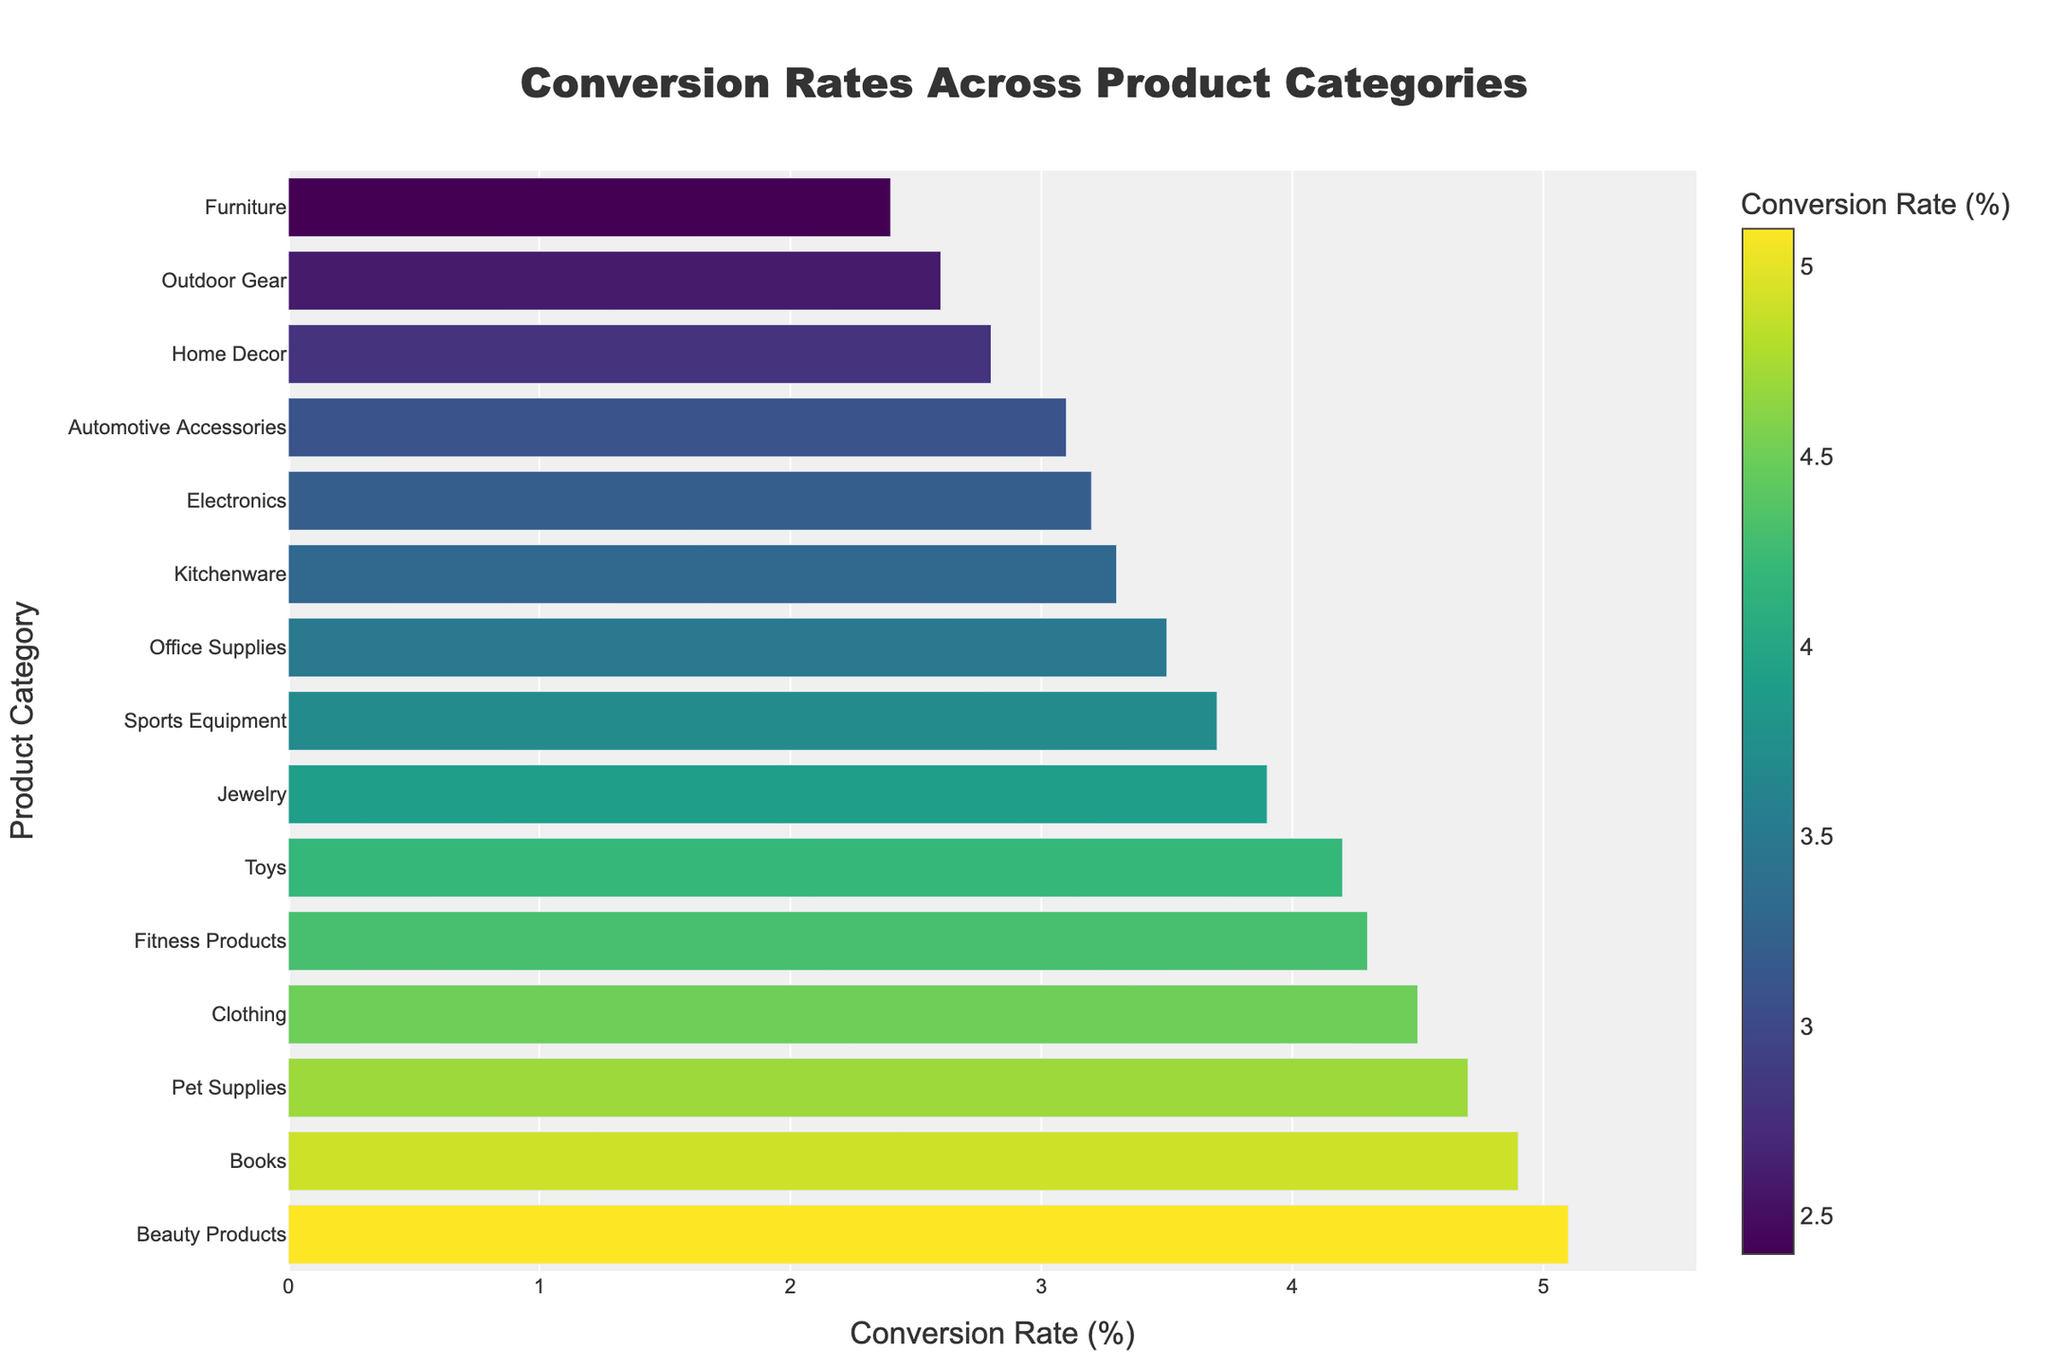Which product category has the highest conversion rate? To find the highest conversion rate, we look for the tallest bar in the bar chart. The tallest bar corresponds to Beauty Products.
Answer: Beauty Products Which product categories have conversion rates higher than 4%? We need to identify the bars with lengths indicating conversion rates above 4%. These categories are Clothing, Beauty Products, Books, Toys, Pet Supplies, and Fitness Products.
Answer: Clothing, Beauty Products, Books, Toys, Pet Supplies, Fitness Products What's the difference in conversion rate between Electronics and Jewelry? We locate the bars for Electronics and Jewelry and note their conversion rates. The rates are 3.2 for Electronics and 3.9 for Jewelry. The difference is calculated as 3.9 - 3.2.
Answer: 0.7% What is the average conversion rate of the top three product categories? Identify the top three product categories by conversion rate: Beauty Products (5.1), Books (4.9), and Pet Supplies (4.7). Sum these rates: 5.1 + 4.9 + 4.7 = 14.7, and then divide by 3 for the average.
Answer: 4.9% How does Home Decor's conversion rate compare to the overall average conversion rate? First, calculate the overall average conversion rate by summing all conversion rates and dividing by the number of categories. The sum is 54.6, and there are 15 categories, so the average is 54.6 / 15 = 3.64%. Home Decor's conversion rate is 2.8%. Compare this with the overall average.
Answer: Home Decor's conversion rate is lower than the overall average Which product category has the least conversion rate, and what is it? Identify the shortest bar in the bar chart to find the category with the lowest conversion rate. The shortest bar corresponds to Furniture.
Answer: Furniture, 2.4% What is the sum of conversion rates for categories with rates below 3%? Identify categories with conversion rates below 3%: Home Decor (2.8), Outdoor Gear (2.6), and Furniture (2.4). Sum these rates: 2.8 + 2.6 + 2.4.
Answer: 7.8% How many categories have conversion rates between 3% and 4%? Count the number of bars whose lengths correspond to conversion rates between 3% and 4%. The categories are Electronics (3.2), Kitchenware (3.3), Office Supplies (3.5), Automotive Accessories (3.1), and Jewelry (3.9).
Answer: 5 Which product category shows the closest conversion rate to the median rate of all categories? First, arrange conversion rates in ascending order and find the median (8th value): 2.4, 2.6, 2.8, 3.1, 3.2, 3.3, 3.5, 3.7, 3.9, 4.2, 4.3, 4.5, 4.7, 4.9, 5.1; The median is 3.7, which corresponds to Sports Equipment.
Answer: Sports Equipment What is the range of the conversion rates from the highest to the lowest product category? Identify the highest conversion rate (Beauty Products, 5.1) and the lowest conversion rate (Furniture, 2.4). Subtract the lowest rate from the highest: 5.1 - 2.4.
Answer: 2.7% 